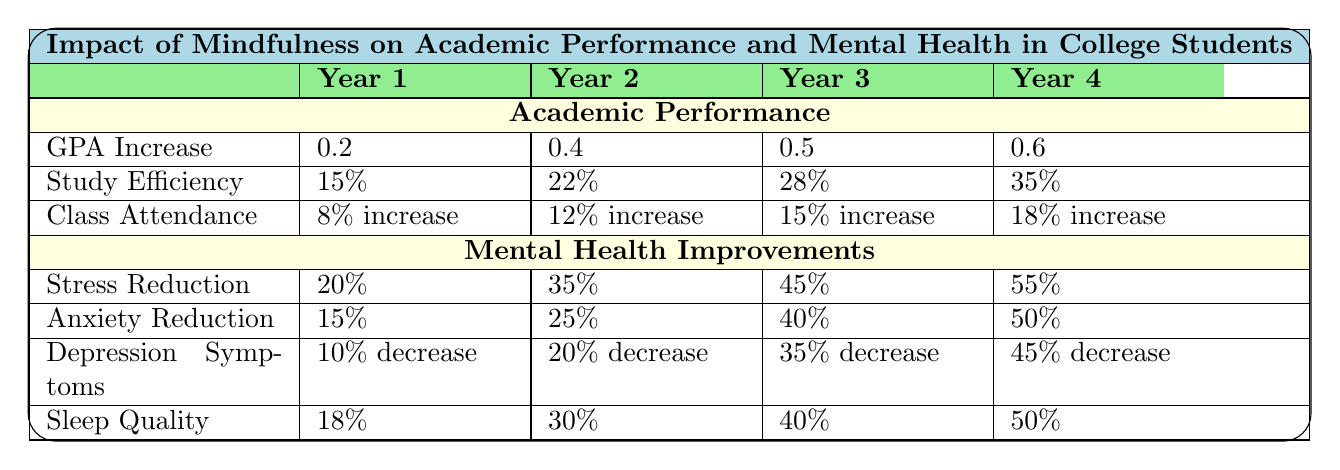What was the GPA increase in Year 3? According to the table, the GPA increase in Year 3 is listed as 0.5.
Answer: 0.5 What percentage did class attendance increase in Year 2? The table shows that class attendance increased by 12% in Year 2.
Answer: 12% What is the average GPA increase over the four years? The GPA increases are 0.2, 0.4, 0.5, and 0.6. To find the average, sum them: (0.2 + 0.4 + 0.5 + 0.6) = 1.7, then divide by 4: 1.7/4 = 0.425.
Answer: 0.425 In which year was the highest percentage of stress reduction observed? From the table, the highest percentage of stress reduction is 55%, which occurred in Year 4.
Answer: Year 4 Did the anxiety reduction improve by more than 30% in Year 3? The table indicates that anxiety reduction is 40% in Year 3, which is indeed more than 30%.
Answer: Yes What is the total percentage increase in class attendance over the four years? The increases in class attendance are 8%, 12%, 15%, and 18%. Adding these values together gives 8 + 12 + 15 + 18 = 53%.
Answer: 53% Is the decrease in depression symptoms more significant from Year 3 to Year 4 compared to the decrease from Year 1 to Year 2? The decrease in depression symptoms from Year 3 (35%) to Year 4 (45%) is 10%, while from Year 1 (10%) to Year 2 (20%) is also 10%. Thus, they are the same.
Answer: No Which mindfulness intervention corresponds with the highest reported study efficiency improvement? The highest reported study efficiency improvement is 35% in Year 4. The table does not specify which intervention corresponds to that year directly.
Answer: Not specified What was the difference in sleep quality improvement between Year 1 and Year 4? The table shows 18% improvement in Year 1 and 50% in Year 4. The difference is 50 - 18 = 32%.
Answer: 32% Was there a consistent increase in GPA over all four years? The table indicates increases of 0.2, 0.4, 0.5, and 0.6 across the years, which shows a consistent increase each year.
Answer: Yes 